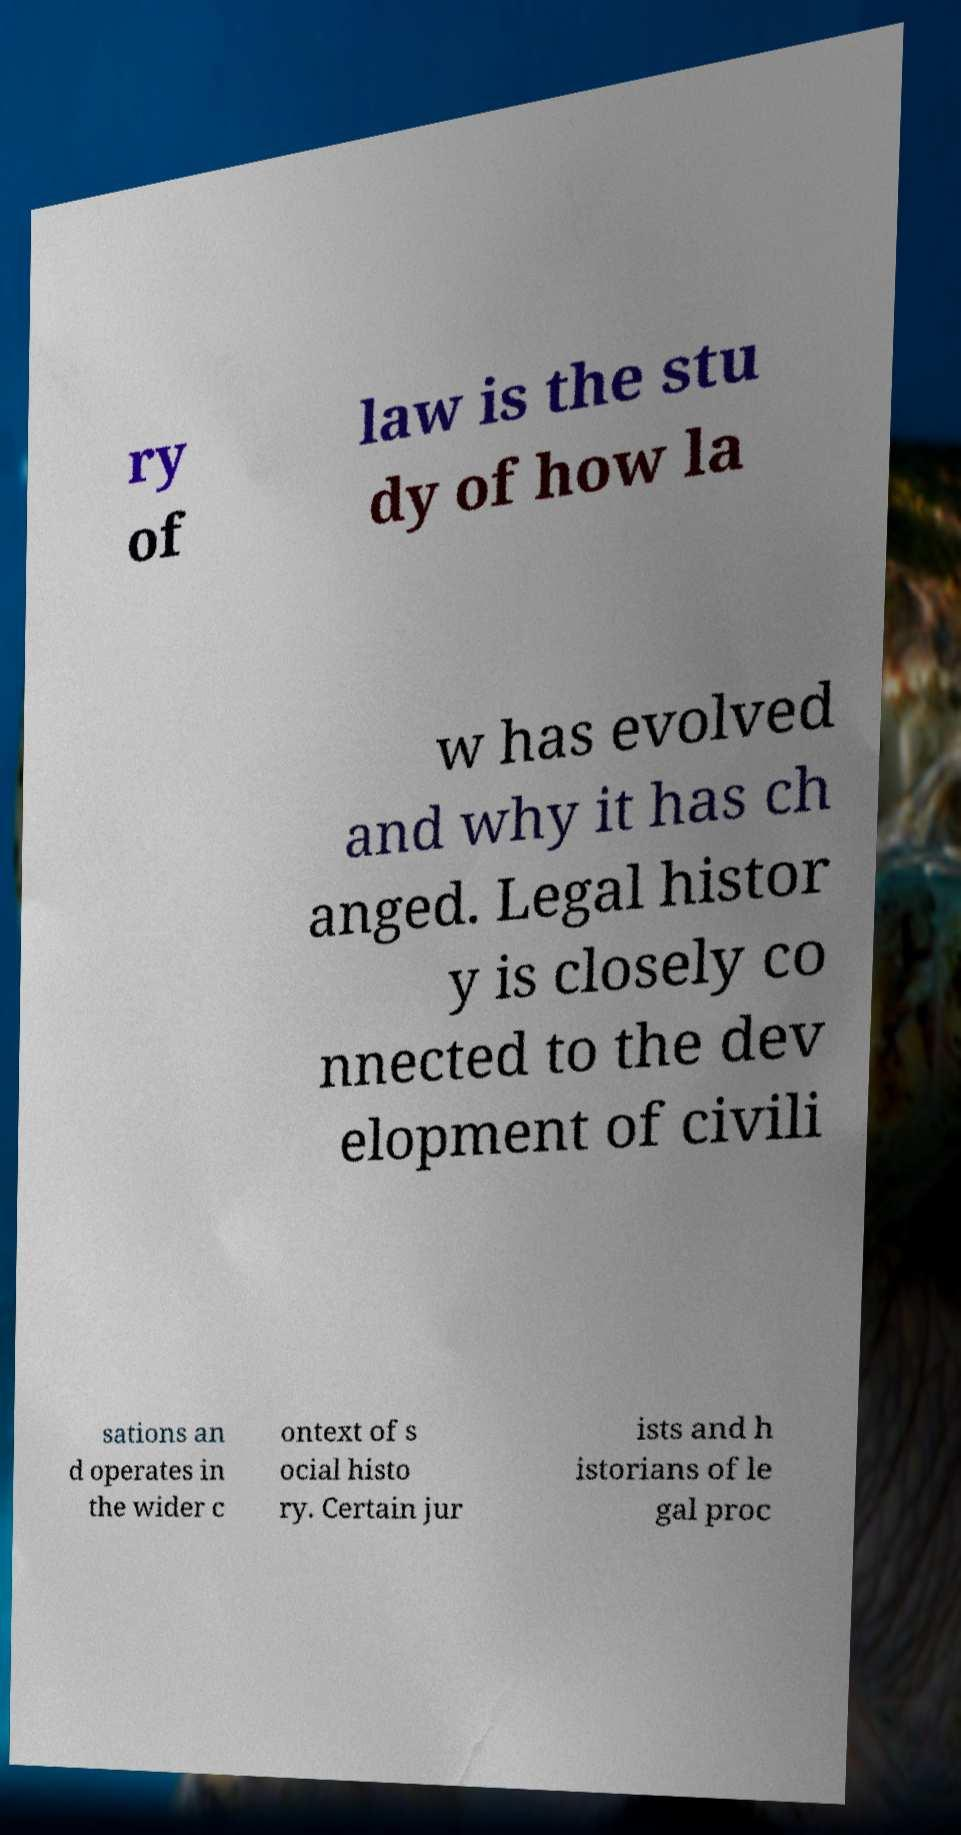Can you read and provide the text displayed in the image?This photo seems to have some interesting text. Can you extract and type it out for me? ry of law is the stu dy of how la w has evolved and why it has ch anged. Legal histor y is closely co nnected to the dev elopment of civili sations an d operates in the wider c ontext of s ocial histo ry. Certain jur ists and h istorians of le gal proc 